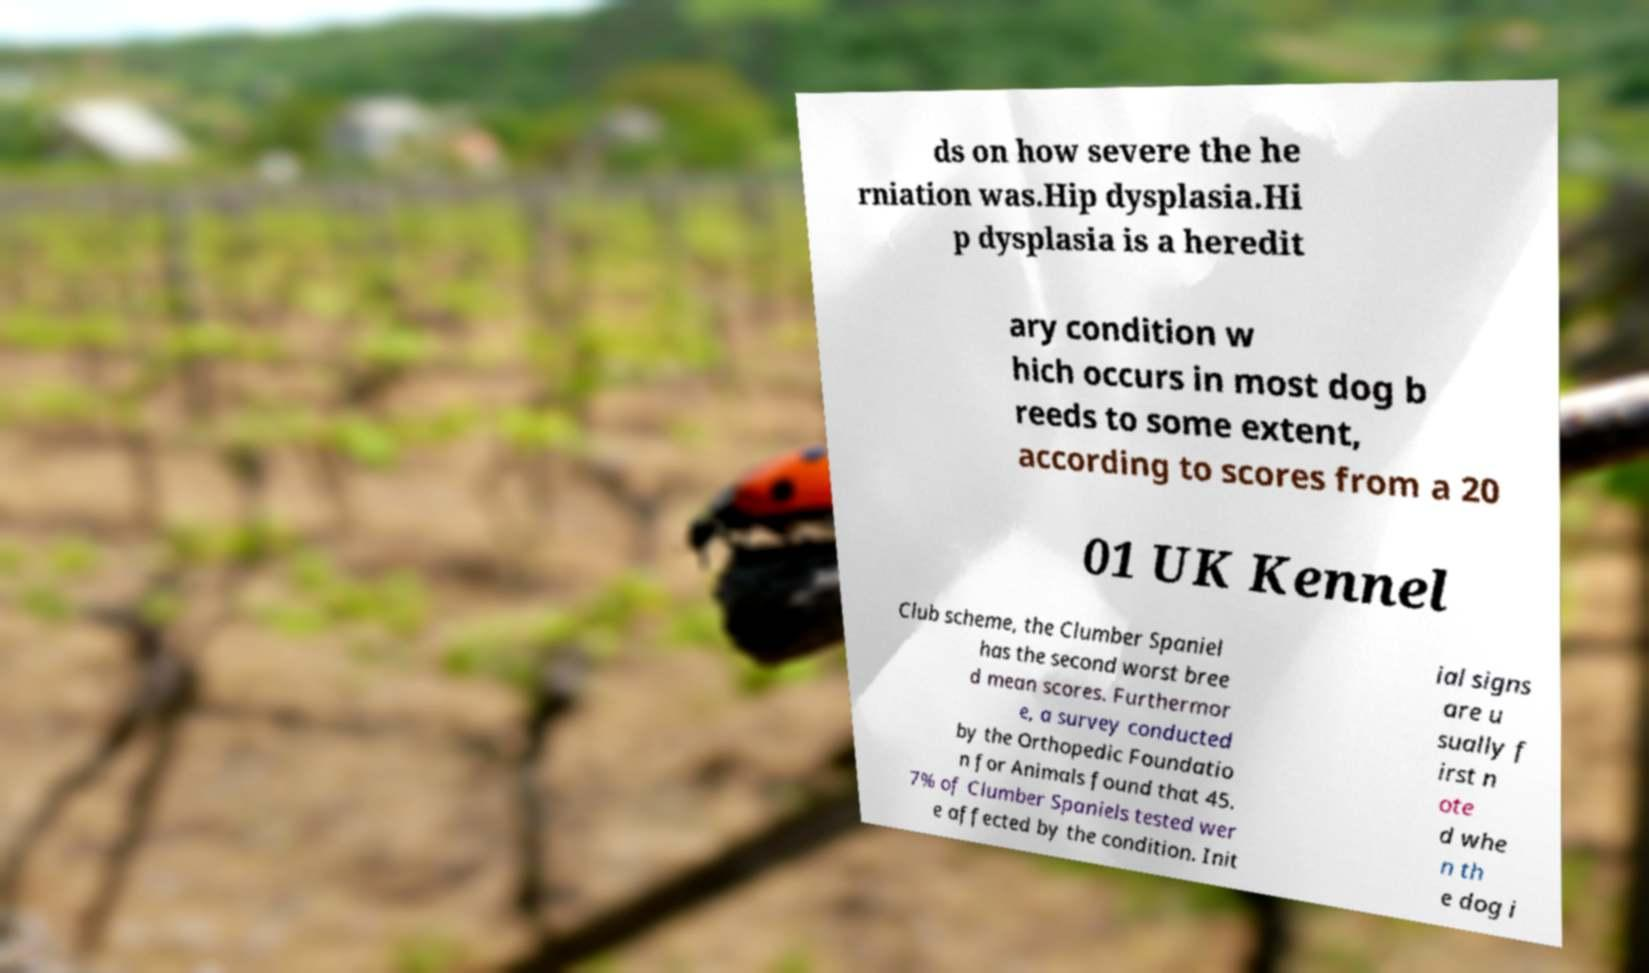For documentation purposes, I need the text within this image transcribed. Could you provide that? ds on how severe the he rniation was.Hip dysplasia.Hi p dysplasia is a heredit ary condition w hich occurs in most dog b reeds to some extent, according to scores from a 20 01 UK Kennel Club scheme, the Clumber Spaniel has the second worst bree d mean scores. Furthermor e, a survey conducted by the Orthopedic Foundatio n for Animals found that 45. 7% of Clumber Spaniels tested wer e affected by the condition. Init ial signs are u sually f irst n ote d whe n th e dog i 